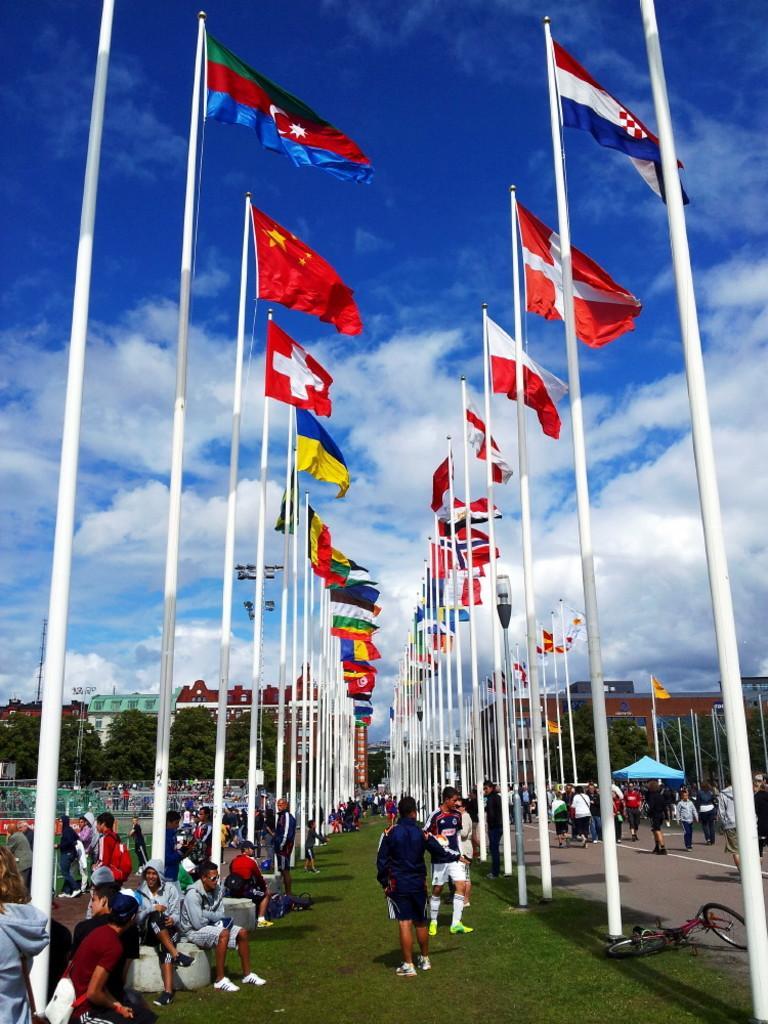Please provide a concise description of this image. In this picture we can see some grass on the ground. There are a few flags on the path. We can see some people on the road. There is a tent, trees and buildings in the background. Sky is blue in color and cloudy. 